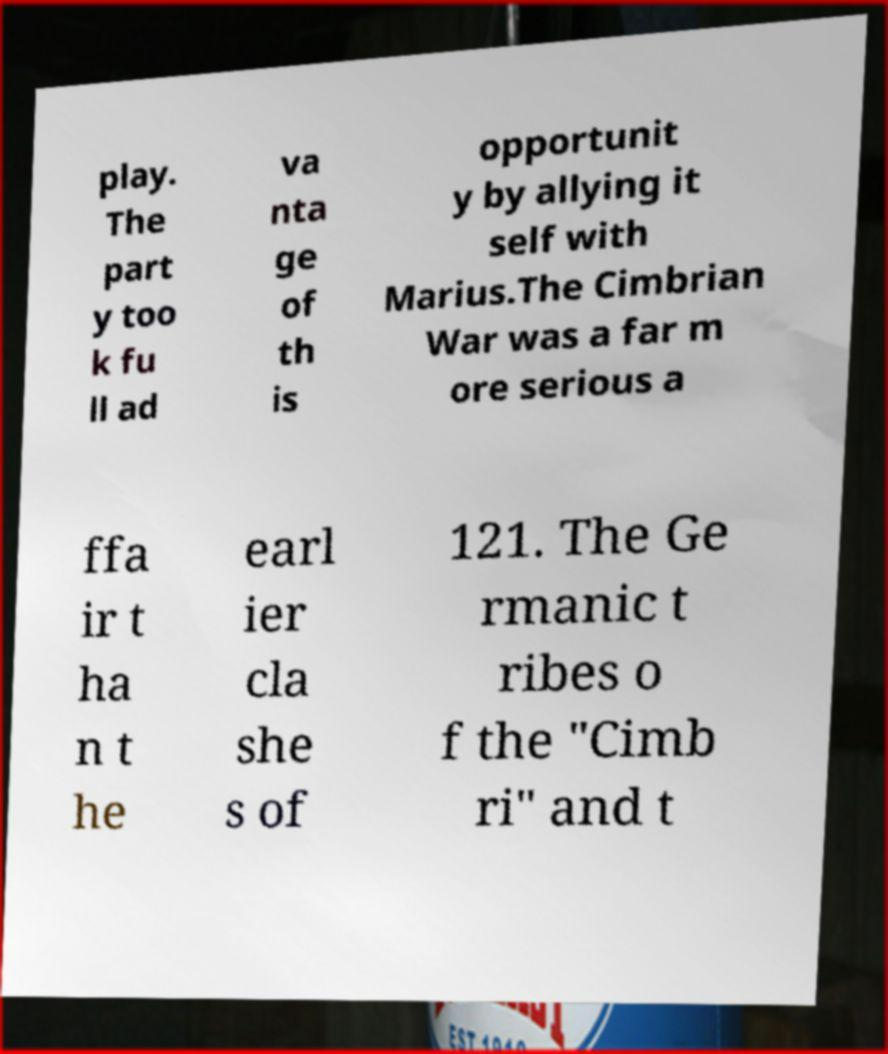For documentation purposes, I need the text within this image transcribed. Could you provide that? play. The part y too k fu ll ad va nta ge of th is opportunit y by allying it self with Marius.The Cimbrian War was a far m ore serious a ffa ir t ha n t he earl ier cla she s of 121. The Ge rmanic t ribes o f the "Cimb ri" and t 